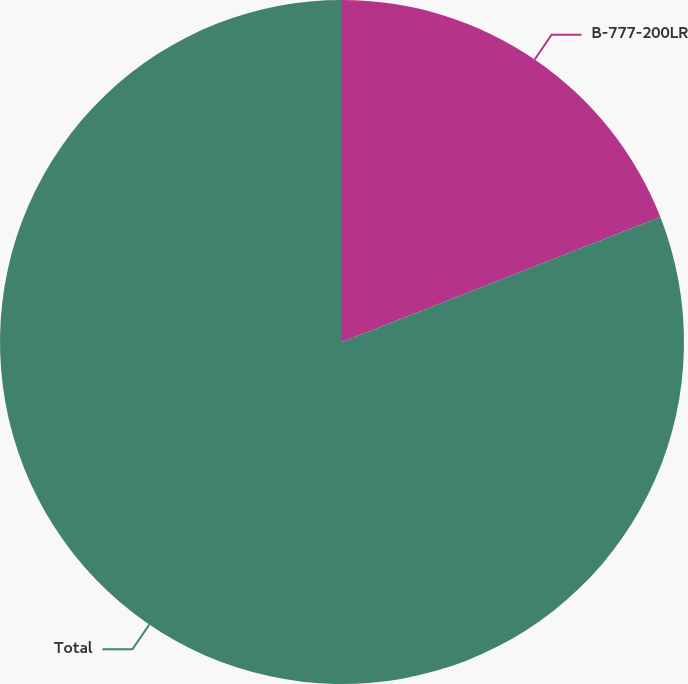<chart> <loc_0><loc_0><loc_500><loc_500><pie_chart><fcel>B-777-200LR<fcel>Total<nl><fcel>19.05%<fcel>80.95%<nl></chart> 